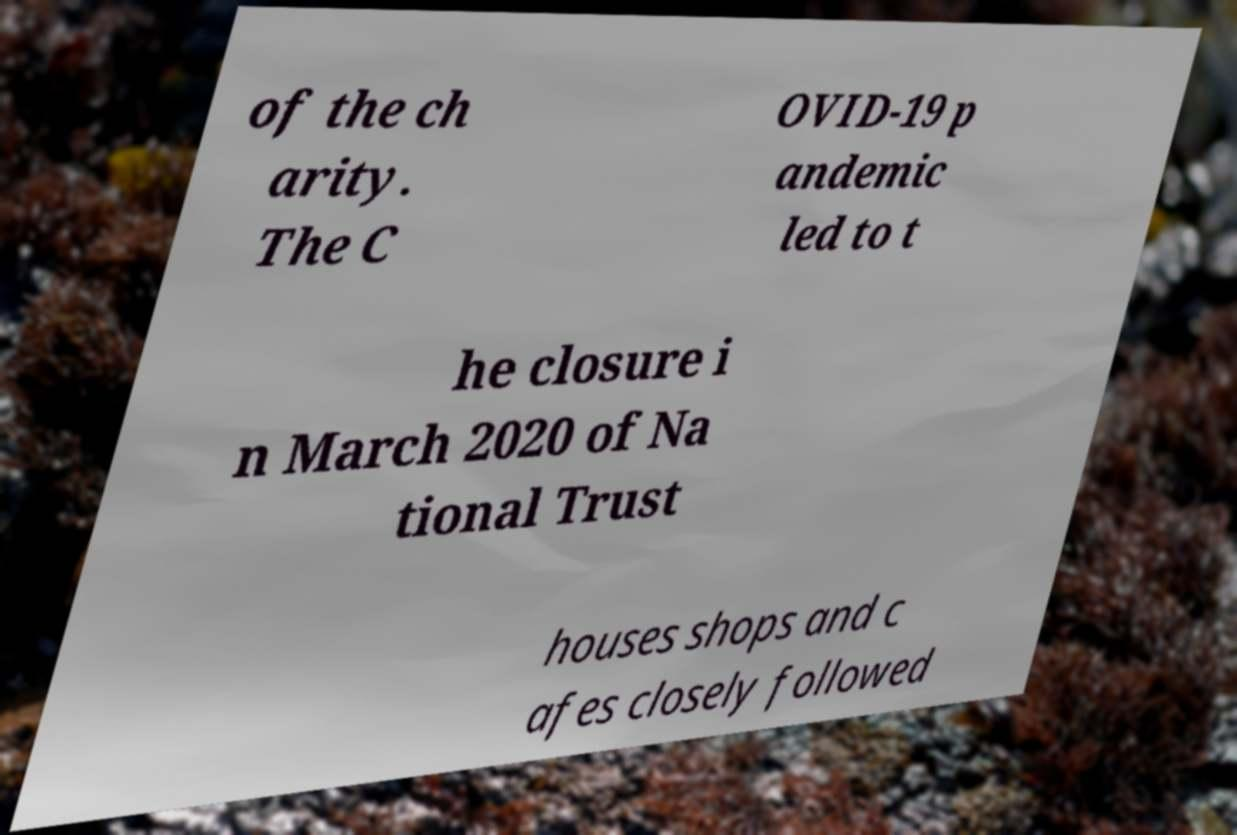What messages or text are displayed in this image? I need them in a readable, typed format. of the ch arity. The C OVID-19 p andemic led to t he closure i n March 2020 of Na tional Trust houses shops and c afes closely followed 